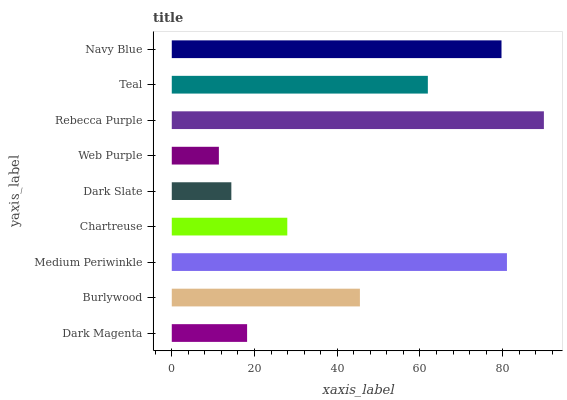Is Web Purple the minimum?
Answer yes or no. Yes. Is Rebecca Purple the maximum?
Answer yes or no. Yes. Is Burlywood the minimum?
Answer yes or no. No. Is Burlywood the maximum?
Answer yes or no. No. Is Burlywood greater than Dark Magenta?
Answer yes or no. Yes. Is Dark Magenta less than Burlywood?
Answer yes or no. Yes. Is Dark Magenta greater than Burlywood?
Answer yes or no. No. Is Burlywood less than Dark Magenta?
Answer yes or no. No. Is Burlywood the high median?
Answer yes or no. Yes. Is Burlywood the low median?
Answer yes or no. Yes. Is Web Purple the high median?
Answer yes or no. No. Is Teal the low median?
Answer yes or no. No. 